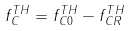<formula> <loc_0><loc_0><loc_500><loc_500>f _ { C } ^ { T H } = f _ { C 0 } ^ { T H } - f _ { C R } ^ { T H }</formula> 